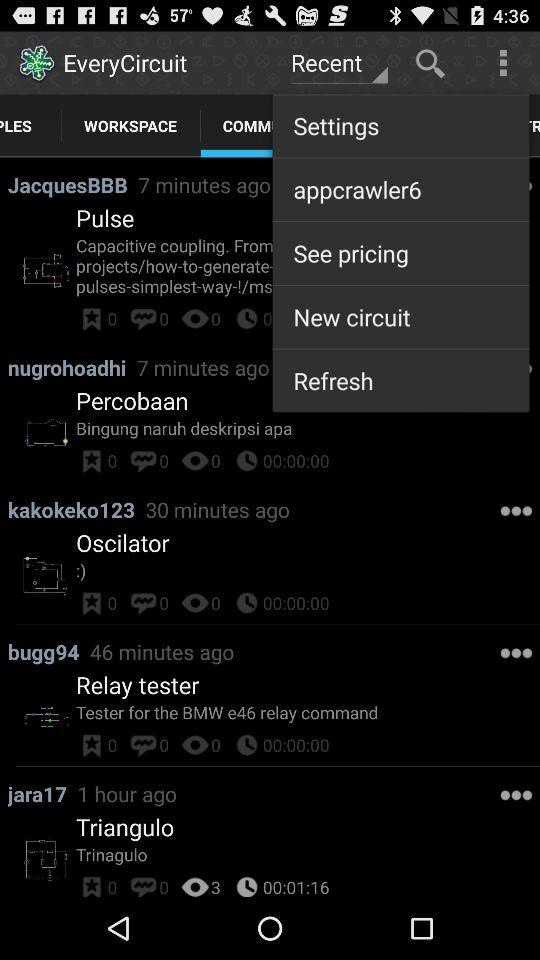How many comments are there for "Oscilator"? There are 0 comments for "Oscilator". 